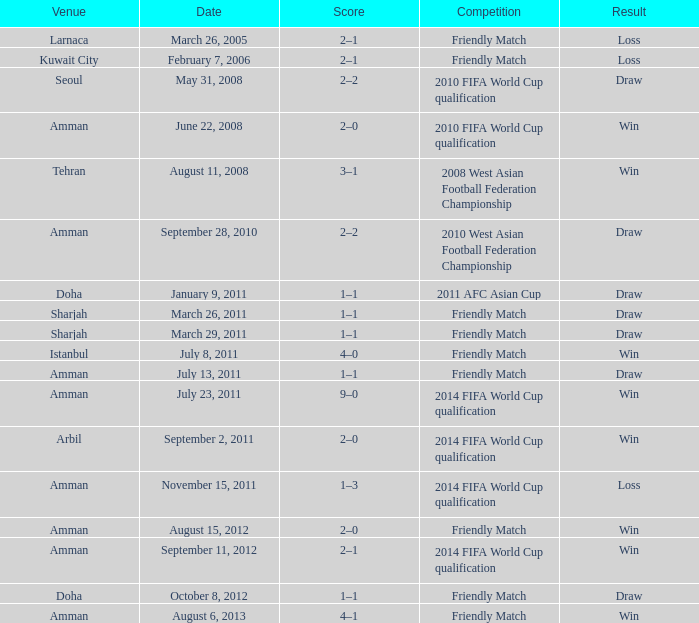What was the name of the competition that took place on may 31, 2008? 2010 FIFA World Cup qualification. 